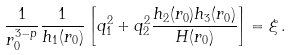Convert formula to latex. <formula><loc_0><loc_0><loc_500><loc_500>\frac { 1 } { r _ { 0 } ^ { 3 - p } } \frac { 1 } { h _ { 1 } ( r _ { 0 } ) } \left [ q _ { 1 } ^ { 2 } + q _ { 2 } ^ { 2 } \frac { h _ { 2 } ( r _ { 0 } ) h _ { 3 } ( r _ { 0 } ) } { H ( r _ { 0 } ) } \right ] = \xi \, .</formula> 